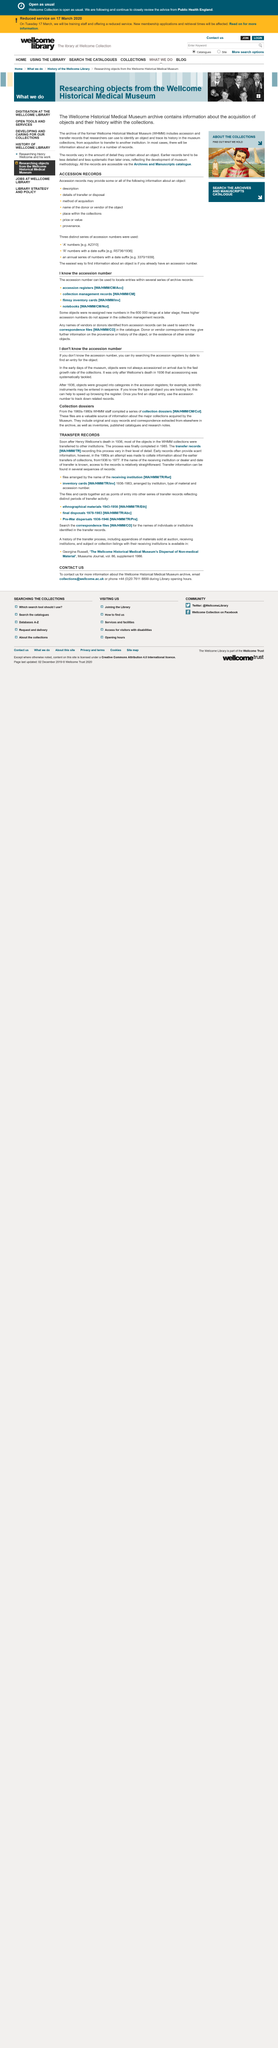Indicate a few pertinent items in this graphic. Transfer information can be found in several sequences of records in the records. Henry Wellcome died in 1936. To find the accession number, search the accession registers by date to locate an entry for the object. Accessioning began after the death of Wellcome in 1936. The process was completed in 1985. 